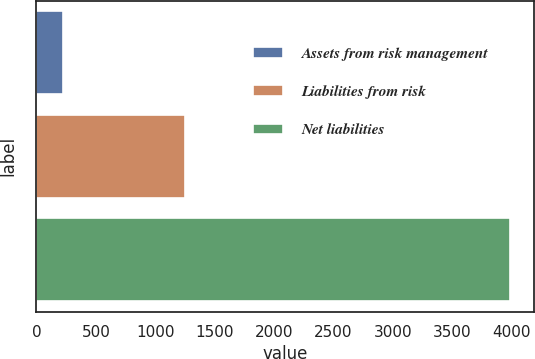Convert chart to OTSL. <chart><loc_0><loc_0><loc_500><loc_500><bar_chart><fcel>Assets from risk management<fcel>Liabilities from risk<fcel>Net liabilities<nl><fcel>225<fcel>1249<fcel>3990<nl></chart> 